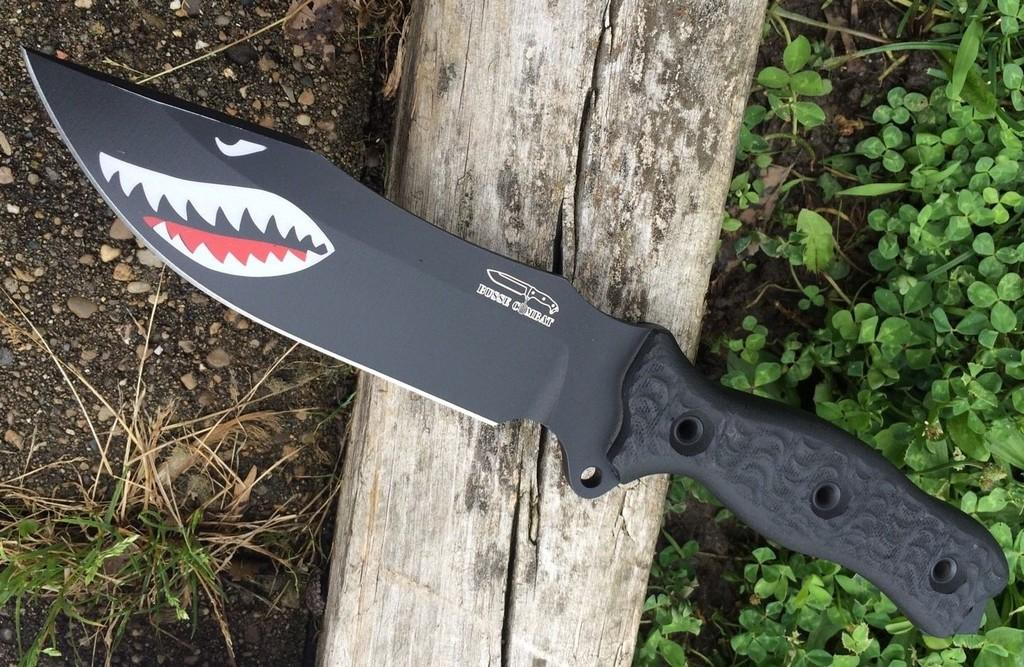What type of knife is in the image? There is a black knife in the image. Where is the knife placed? The knife is placed on a wooden block. What type of vegetation is present in the image? The plants appear to be grass. What else can be seen on the ground in the image? Small stones are visible on the ground in the image. What type of metal is the wren made of in the image? There is no wren present in the image, so it is not possible to determine what type of metal it might be made of. What is the nose doing in the image? There is no nose present in the image, so it is not possible to describe its actions or purpose. 